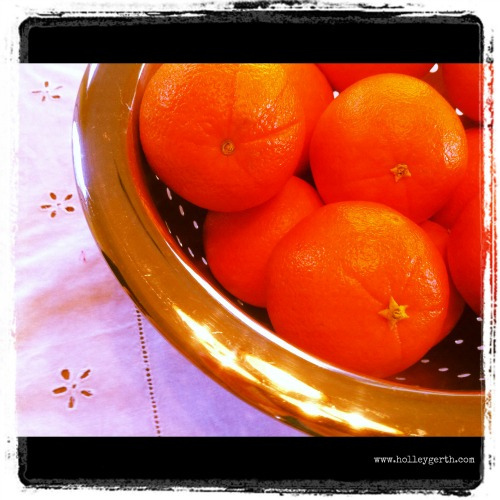Read and extract the text from this image. www.hollgerth.com 